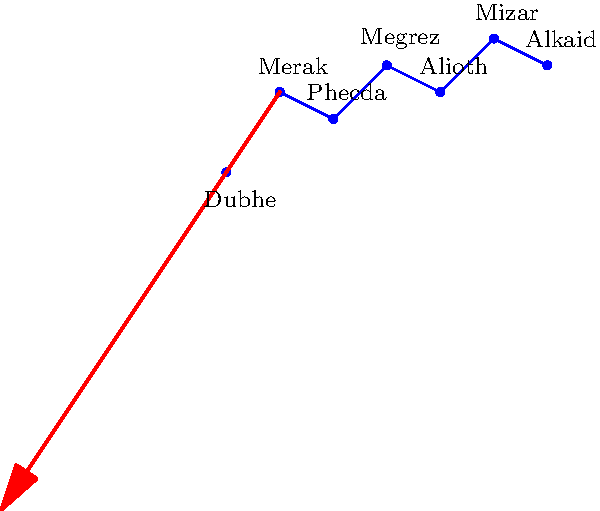As a reproductive health activist in Texas, you might find yourself needing to navigate at night. How can you use the Big Dipper (part of Ursa Major) to locate the North Star (Polaris), which is crucial for determining direction? To locate Polaris using the Big Dipper, follow these steps:

1. Identify the Big Dipper constellation, which is part of Ursa Major. It consists of seven bright stars forming a shape resembling a large ladle or dipper.

2. Focus on the two stars at the front edge of the dipper's bowl, farthest from the handle. These are Dubhe and Merak.

3. Draw an imaginary line connecting Merak to Dubhe, then extend this line about five times its length.

4. At the end of this imaginary line, you'll find Polaris, the North Star.

5. Polaris is the last star in the handle of the Little Dipper (Ursa Minor) constellation.

6. Once you've located Polaris, you can determine the cardinal directions:
   - Polaris always points north
   - South is directly opposite Polaris
   - East is 90 degrees clockwise from Polaris
   - West is 90 degrees counterclockwise from Polaris

This method works regardless of the Big Dipper's orientation in the sky, which changes throughout the night and seasons. The Big Dipper is circumpolar in the Northern Hemisphere, meaning it's visible year-round, making it a reliable navigation tool.
Answer: Use the two front stars of the Big Dipper's bowl to create a line; extend it 5 times to find Polaris. 